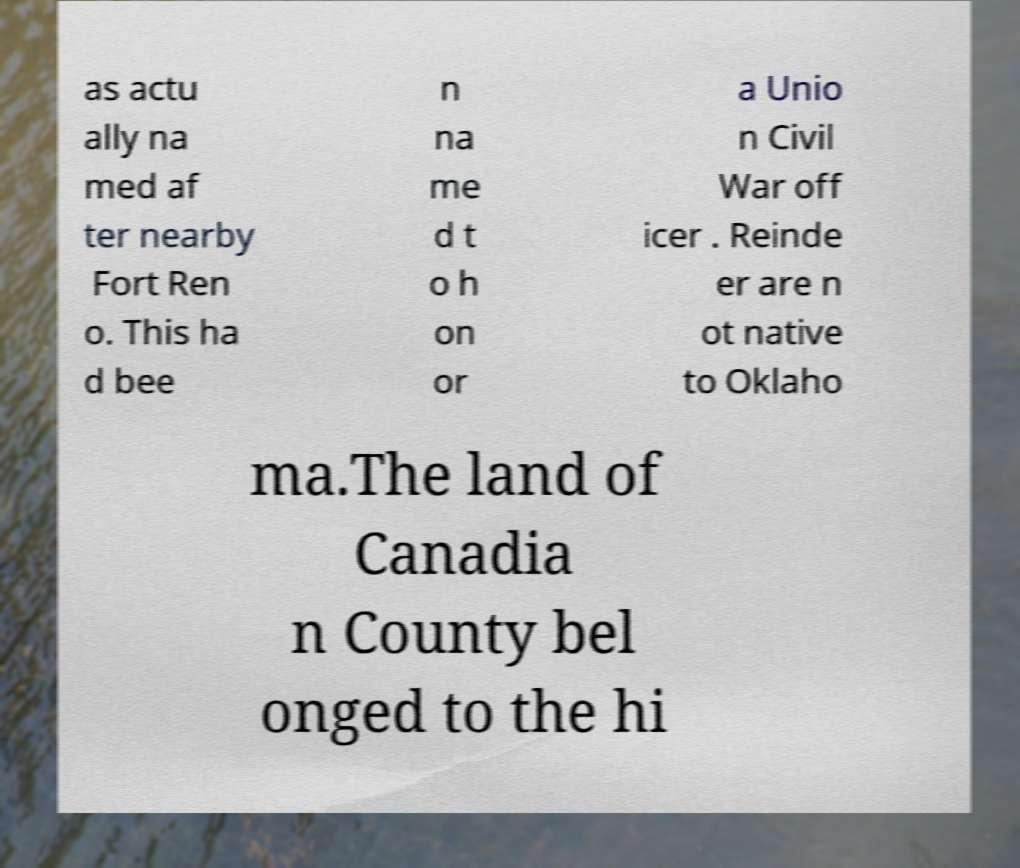Can you read and provide the text displayed in the image?This photo seems to have some interesting text. Can you extract and type it out for me? as actu ally na med af ter nearby Fort Ren o. This ha d bee n na me d t o h on or a Unio n Civil War off icer . Reinde er are n ot native to Oklaho ma.The land of Canadia n County bel onged to the hi 